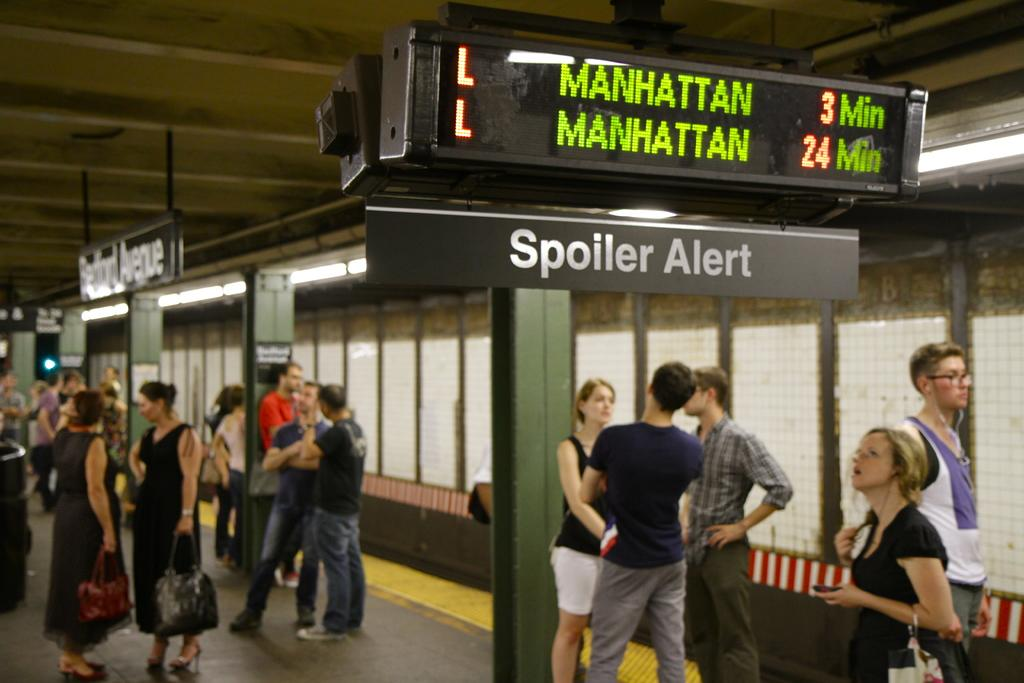What are the people in the image doing? The people are standing at the bottom of the image and watching something. What is behind the people in the image? There is a wall behind the people. What is visible on the roof in the image? There are banners and screens on the roof. What type of zipper can be seen on the banners in the image? There are no zippers present on the banners in the image. What taste do the screens on the roof have in the image? The screens on the roof do not have a taste, as they are not edible objects. 